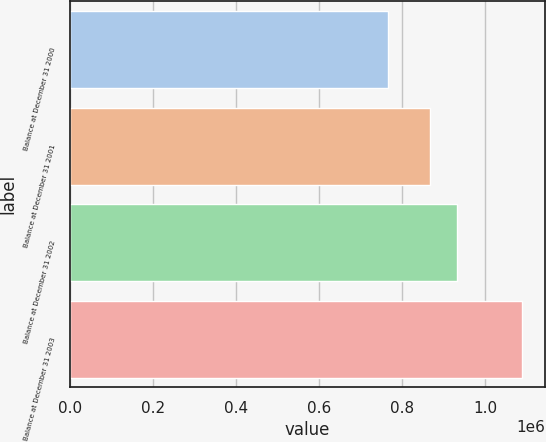Convert chart to OTSL. <chart><loc_0><loc_0><loc_500><loc_500><bar_chart><fcel>Balance at December 31 2000<fcel>Balance at December 31 2001<fcel>Balance at December 31 2002<fcel>Balance at December 31 2003<nl><fcel>767206<fcel>867540<fcel>933364<fcel>1.09043e+06<nl></chart> 